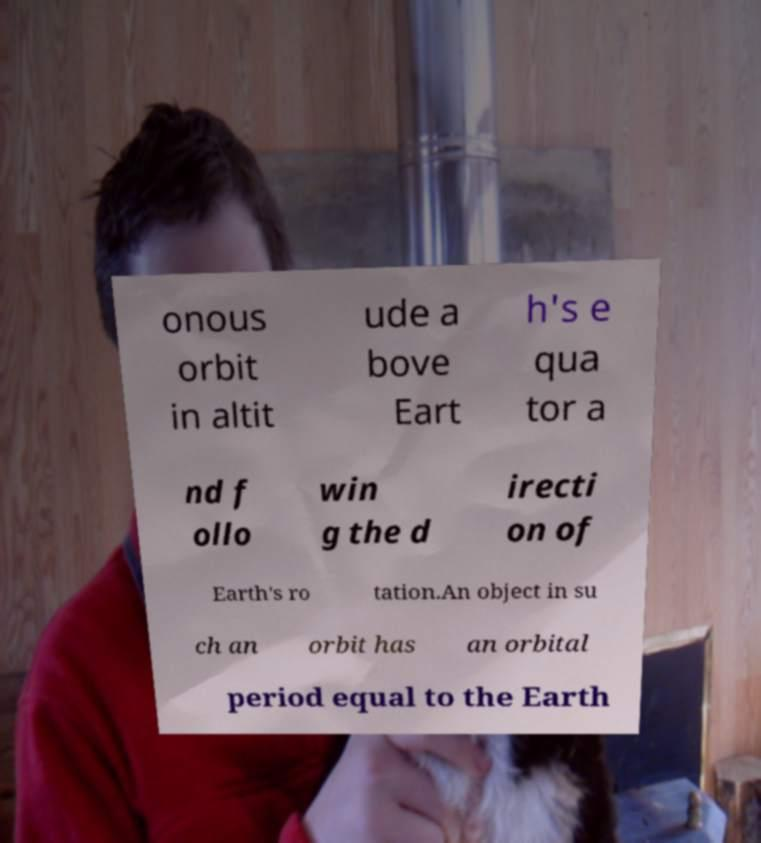Please read and relay the text visible in this image. What does it say? onous orbit in altit ude a bove Eart h's e qua tor a nd f ollo win g the d irecti on of Earth's ro tation.An object in su ch an orbit has an orbital period equal to the Earth 